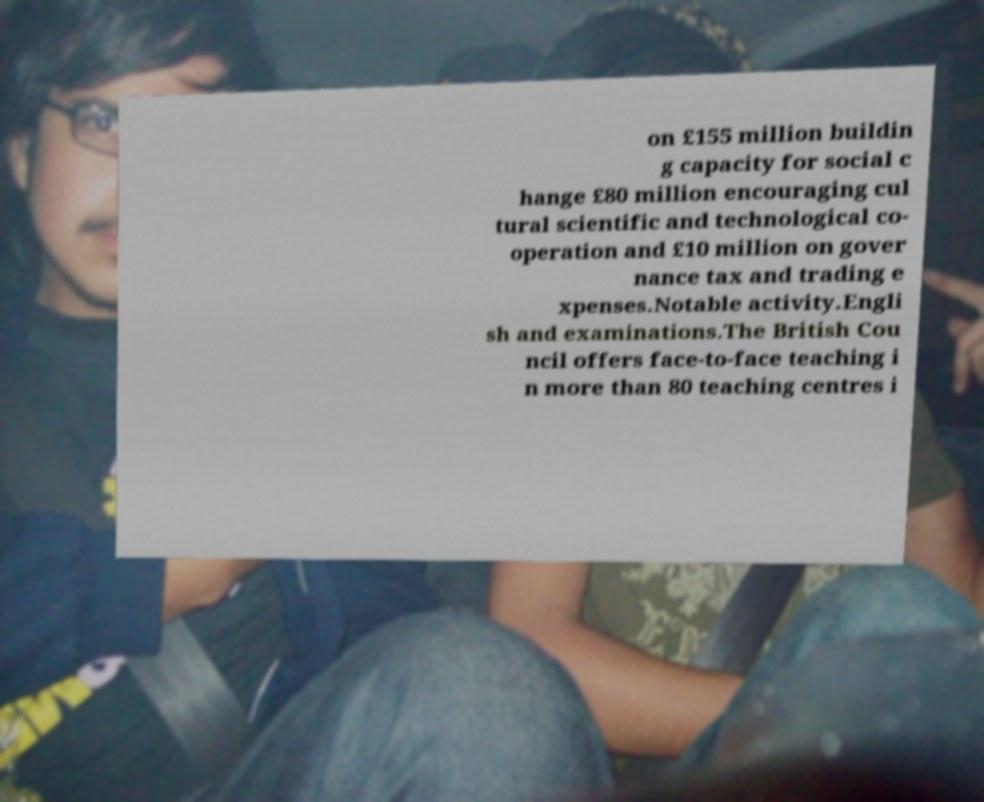Can you read and provide the text displayed in the image?This photo seems to have some interesting text. Can you extract and type it out for me? on £155 million buildin g capacity for social c hange £80 million encouraging cul tural scientific and technological co- operation and £10 million on gover nance tax and trading e xpenses.Notable activity.Engli sh and examinations.The British Cou ncil offers face-to-face teaching i n more than 80 teaching centres i 